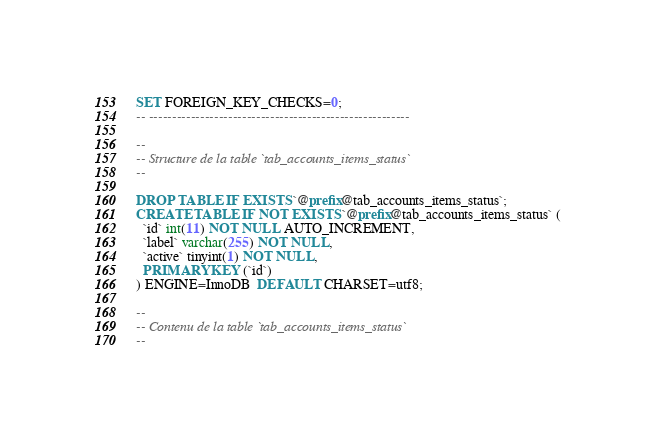<code> <loc_0><loc_0><loc_500><loc_500><_SQL_>SET FOREIGN_KEY_CHECKS=0;
-- --------------------------------------------------------

--
-- Structure de la table `tab_accounts_items_status`
--

DROP TABLE IF EXISTS `@prefix@tab_accounts_items_status`;
CREATE TABLE IF NOT EXISTS `@prefix@tab_accounts_items_status` (
  `id` int(11) NOT NULL AUTO_INCREMENT,
  `label` varchar(255) NOT NULL,
  `active` tinyint(1) NOT NULL,
  PRIMARY KEY (`id`)
) ENGINE=InnoDB  DEFAULT CHARSET=utf8;

--
-- Contenu de la table `tab_accounts_items_status`
--
</code> 